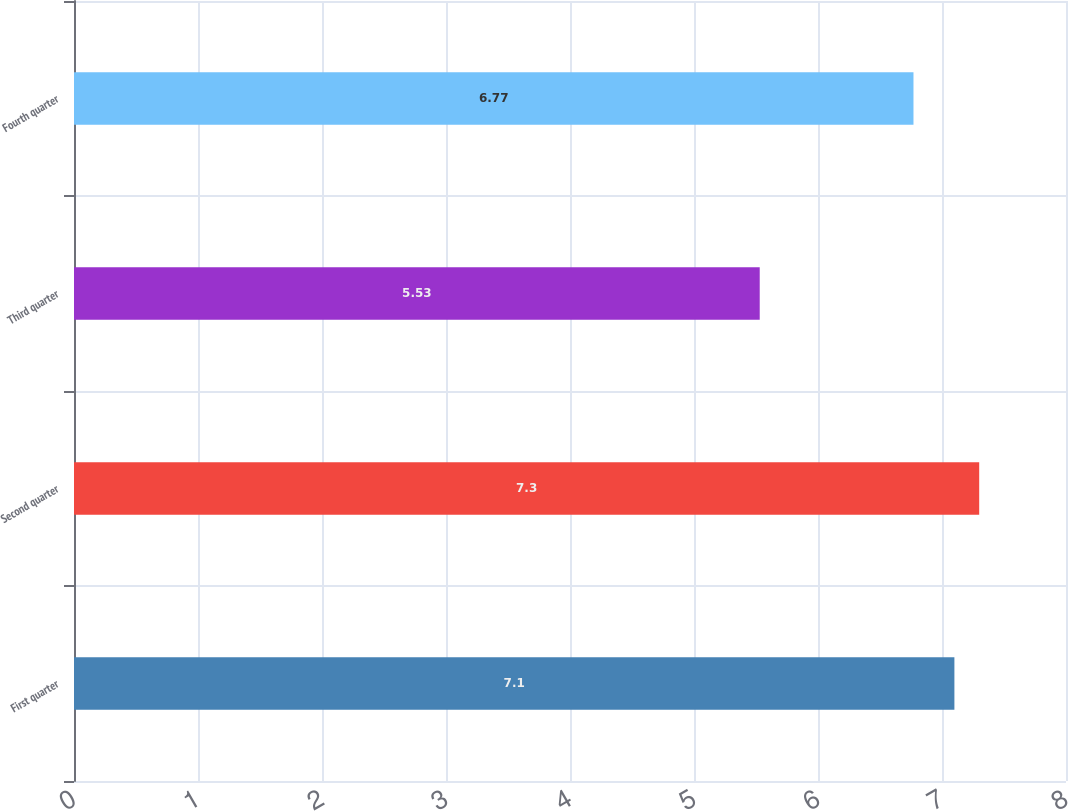Convert chart. <chart><loc_0><loc_0><loc_500><loc_500><bar_chart><fcel>First quarter<fcel>Second quarter<fcel>Third quarter<fcel>Fourth quarter<nl><fcel>7.1<fcel>7.3<fcel>5.53<fcel>6.77<nl></chart> 